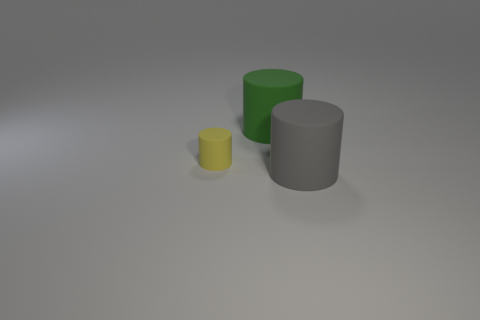Subtract all green cylinders. Subtract all green spheres. How many cylinders are left? 2 Add 3 tiny cyan cylinders. How many objects exist? 6 Add 1 tiny objects. How many tiny objects are left? 2 Add 1 small blue cylinders. How many small blue cylinders exist? 1 Subtract 0 red cylinders. How many objects are left? 3 Subtract all large purple cubes. Subtract all large green matte things. How many objects are left? 2 